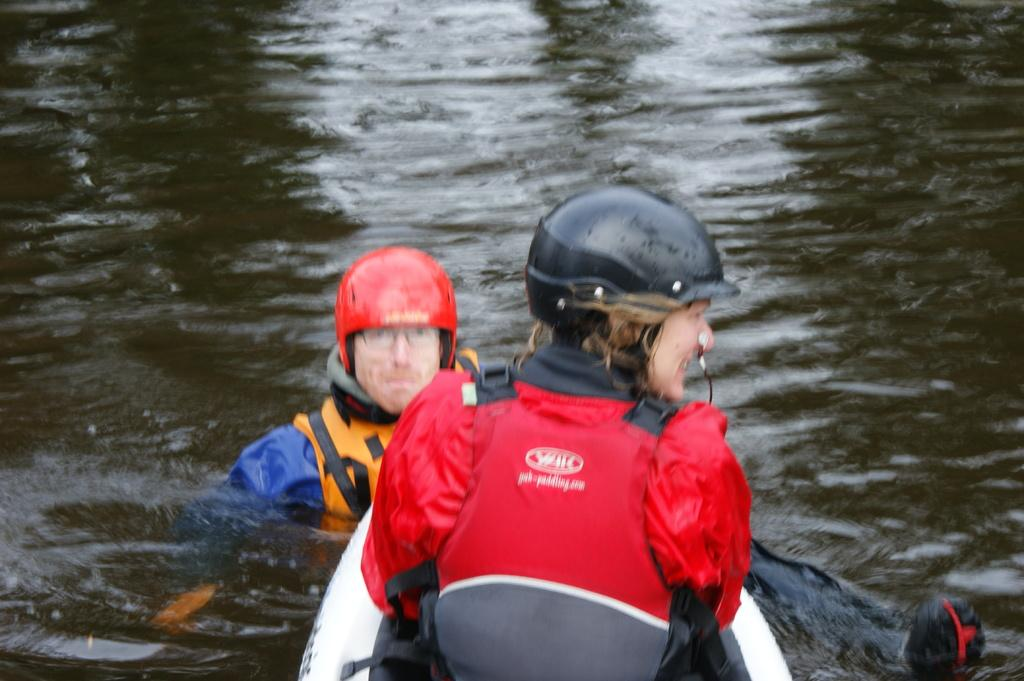What are the people in the image doing? The people in the image are swimming in the water. What protective gear are the people wearing? The people are wearing helmets and life jackets. Reasoning: Let's think step by identifying the main subjects and objects in the image based on the provided facts. We then formulate questions that focus on the actions and protective gear of the people in the image, ensuring that each question can be answered definitively with the information given. We avoid yes/no questions and ensure that the language is simple and clear. Absurd Question/Answer: What type of snails can be seen swimming alongside the people in the image? There are no snails present in the image; it features people swimming in the water while wearing helmets and life jackets. What type of pollution is visible in the water in the image? There is no pollution visible in the water in the image; it only shows people swimming while wearing helmets and life jackets. What type of copper is visible in the image? There is no copper present in the image; it features people swimming in the water while wearing helmets and life jackets. 